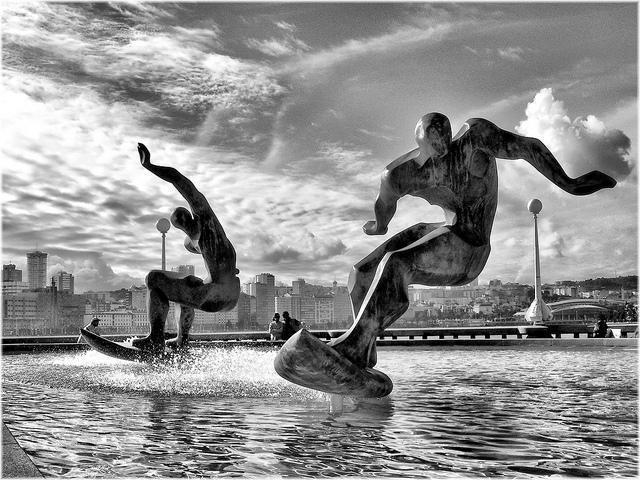What energy powers the splash?
From the following set of four choices, select the accurate answer to respond to the question.
Options: Electricity, solar, wind, manual power. Electricity. 